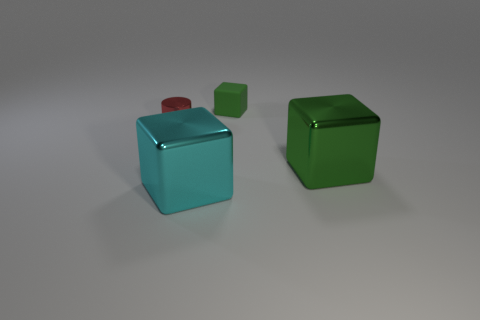Add 4 small purple metal balls. How many objects exist? 8 Subtract all blocks. How many objects are left? 1 Subtract 1 red cylinders. How many objects are left? 3 Subtract all large green objects. Subtract all green metal objects. How many objects are left? 2 Add 1 cyan objects. How many cyan objects are left? 2 Add 4 big cyan shiny blocks. How many big cyan shiny blocks exist? 5 